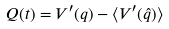Convert formula to latex. <formula><loc_0><loc_0><loc_500><loc_500>Q ( t ) = V ^ { \prime } ( q ) - \langle V ^ { \prime } ( \hat { q } ) \rangle</formula> 